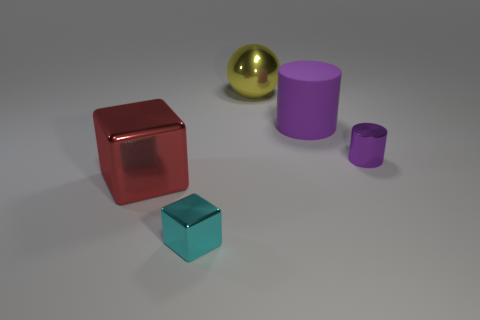Add 1 small cyan shiny things. How many objects exist? 6 Subtract all cylinders. How many objects are left? 3 Add 4 gray spheres. How many gray spheres exist? 4 Subtract 0 blue balls. How many objects are left? 5 Subtract all green things. Subtract all small cyan shiny blocks. How many objects are left? 4 Add 3 metal cubes. How many metal cubes are left? 5 